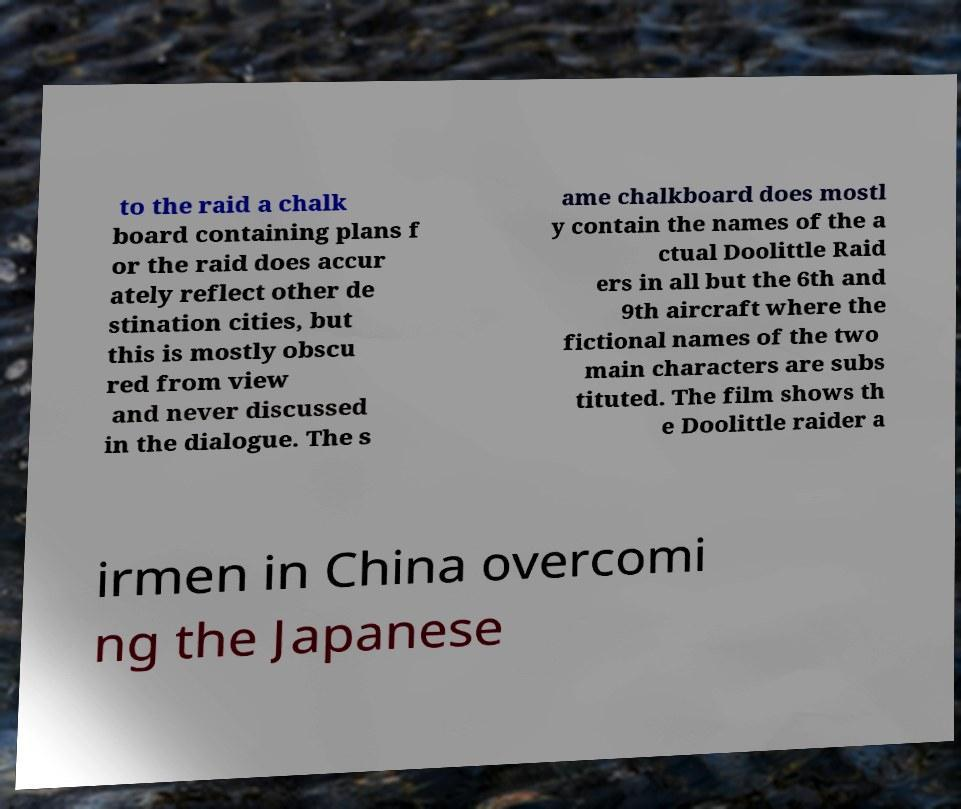Please identify and transcribe the text found in this image. to the raid a chalk board containing plans f or the raid does accur ately reflect other de stination cities, but this is mostly obscu red from view and never discussed in the dialogue. The s ame chalkboard does mostl y contain the names of the a ctual Doolittle Raid ers in all but the 6th and 9th aircraft where the fictional names of the two main characters are subs tituted. The film shows th e Doolittle raider a irmen in China overcomi ng the Japanese 